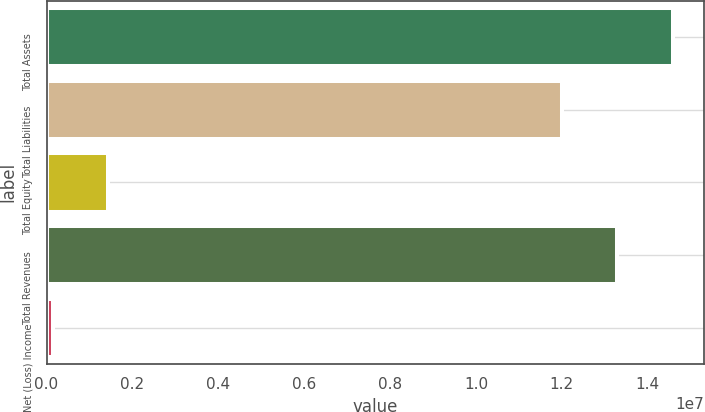Convert chart to OTSL. <chart><loc_0><loc_0><loc_500><loc_500><bar_chart><fcel>Total Assets<fcel>Total Liabilities<fcel>Total Equity<fcel>Total Revenues<fcel>Net (Loss) Income<nl><fcel>1.45784e+07<fcel>1.201e+07<fcel>1.4272e+06<fcel>1.32942e+07<fcel>143000<nl></chart> 